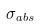<formula> <loc_0><loc_0><loc_500><loc_500>\sigma _ { a b s }</formula> 